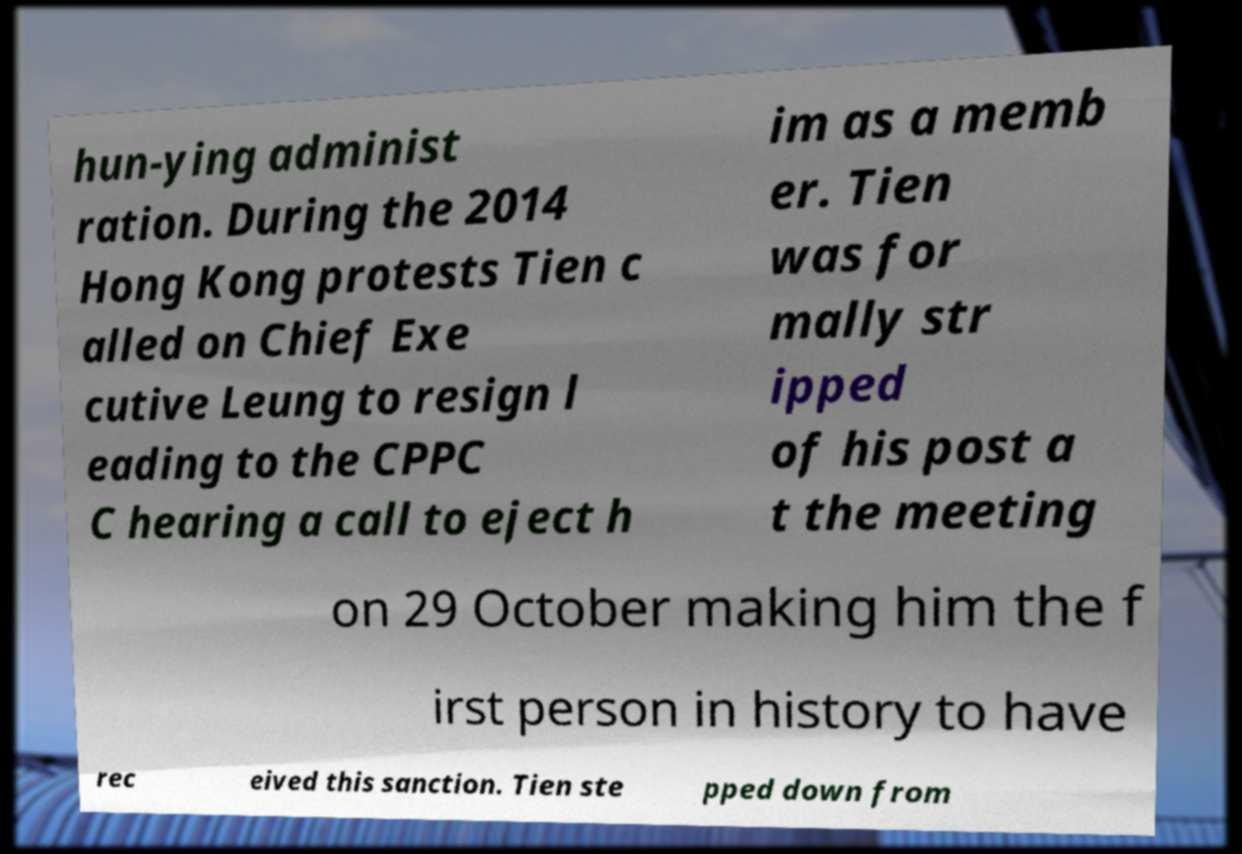Please read and relay the text visible in this image. What does it say? hun-ying administ ration. During the 2014 Hong Kong protests Tien c alled on Chief Exe cutive Leung to resign l eading to the CPPC C hearing a call to eject h im as a memb er. Tien was for mally str ipped of his post a t the meeting on 29 October making him the f irst person in history to have rec eived this sanction. Tien ste pped down from 